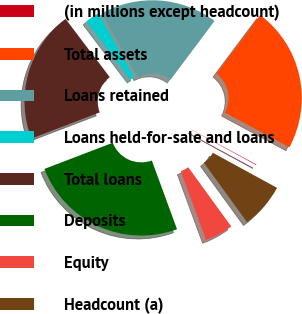<chart> <loc_0><loc_0><loc_500><loc_500><pie_chart><fcel>(in millions except headcount)<fcel>Total assets<fcel>Loans retained<fcel>Loans held-for-sale and loans<fcel>Total loans<fcel>Deposits<fcel>Equity<fcel>Headcount (a)<nl><fcel>0.09%<fcel>22.63%<fcel>18.32%<fcel>2.25%<fcel>20.48%<fcel>24.78%<fcel>4.4%<fcel>7.05%<nl></chart> 